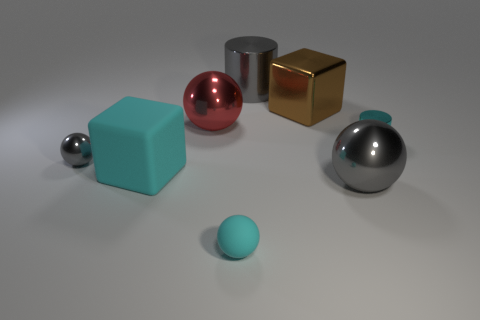What could be the material of the objects and how do we tell? The objects in the image appear to be made from different materials. The shiny metallic sheen on the sphere and cylindrical objects suggests they could be made of polished metals, such as steel or aluminum. We can tell this by their reflective quality and the distinct highlights where the light source hits them. The golden cube might be brass or a gold-plated material, indicated by its lustrous, yellowish hue. The blue cube appears to be more diffuse in its reflection, which could suggest a painted or plastic material, differentiated by its less reflective, uniform surface. 